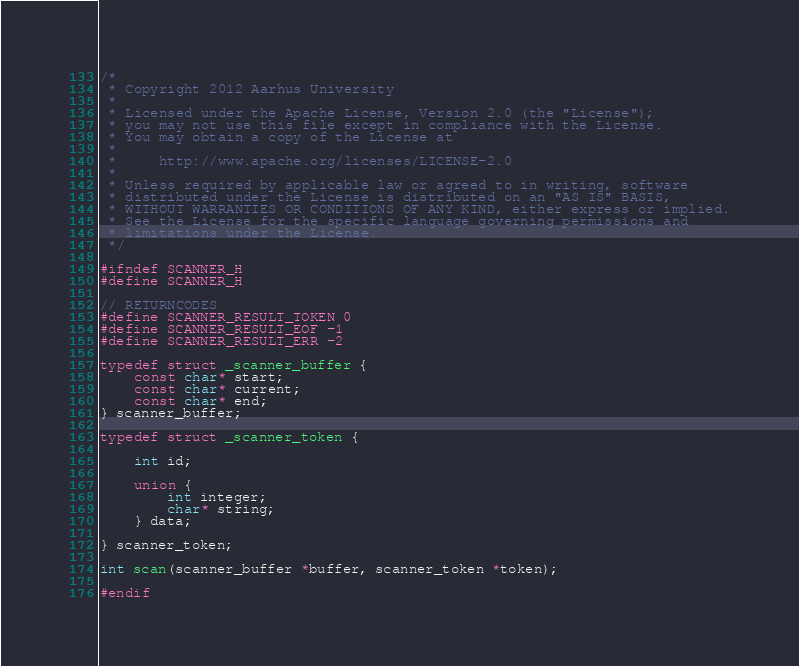Convert code to text. <code><loc_0><loc_0><loc_500><loc_500><_C_>/*
 * Copyright 2012 Aarhus University
 *
 * Licensed under the Apache License, Version 2.0 (the "License");
 * you may not use this file except in compliance with the License.
 * You may obtain a copy of the License at
 *
 *     http://www.apache.org/licenses/LICENSE-2.0
 *
 * Unless required by applicable law or agreed to in writing, software
 * distributed under the License is distributed on an "AS IS" BASIS,
 * WITHOUT WARRANTIES OR CONDITIONS OF ANY KIND, either express or implied.
 * See the License for the specific language governing permissions and
 * limitations under the License.
 */

#ifndef SCANNER_H
#define SCANNER_H

// RETURNCODES
#define SCANNER_RESULT_TOKEN 0
#define SCANNER_RESULT_EOF -1
#define SCANNER_RESULT_ERR -2

typedef struct _scanner_buffer {
	const char* start;
	const char* current;
	const char* end;
} scanner_buffer;

typedef struct _scanner_token {

	int id;

	union {
		int integer;
		char* string;
	} data;

} scanner_token;

int scan(scanner_buffer *buffer, scanner_token *token);

#endif
</code> 